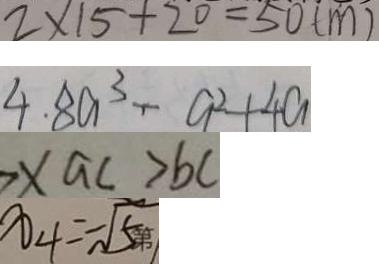<formula> <loc_0><loc_0><loc_500><loc_500>2 \times 1 5 + 2 0 = 5 0 ( m ) 
 4 . 8 a ^ { 3 } - a ^ { 2 } + 4 a 
 > x a c > b c 
 x _ { 4 } = - \sqrt { 5 }</formula> 